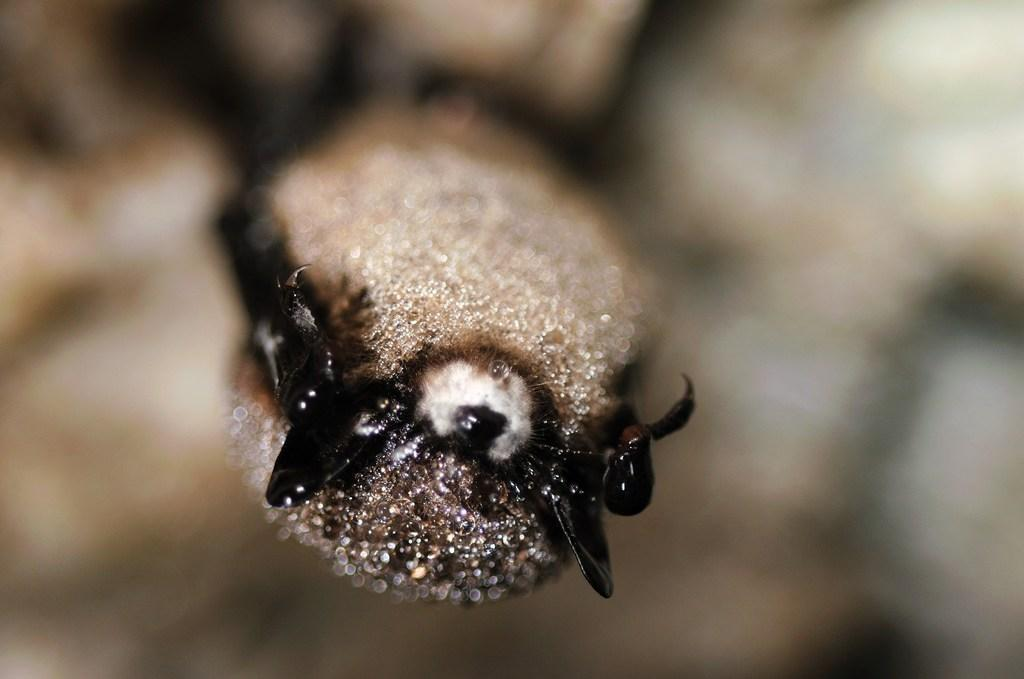What type of creature can be seen in the image? There is an insect in the image. Can you describe the background of the image? The background of the image is blurred. What type of hook is visible in the image? There is no hook present in the image. Can you see an airplane in the image? There is no airplane present in the image. 